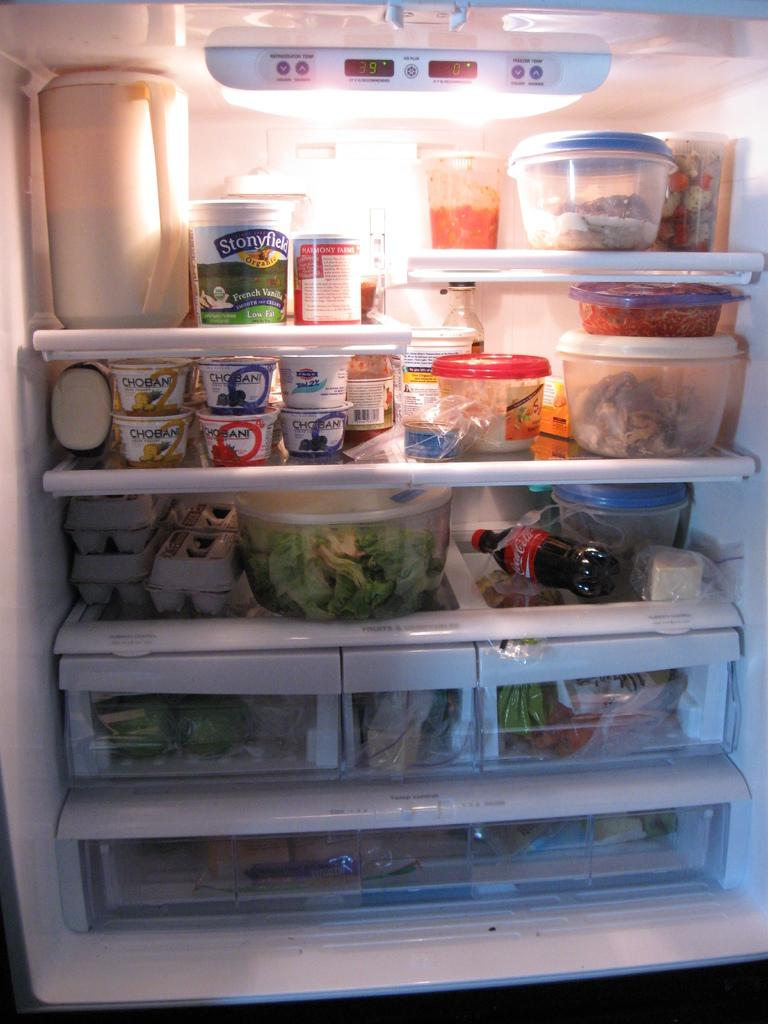<image>
Render a clear and concise summary of the photo. Five containers of Chobani yogurt sit above three cartons of eggs 